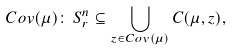<formula> <loc_0><loc_0><loc_500><loc_500>C o v ( \mu ) \colon \, S _ { r } ^ { n } \subseteq \bigcup _ { z \in C o v ( \mu ) } C ( \mu , z ) ,</formula> 